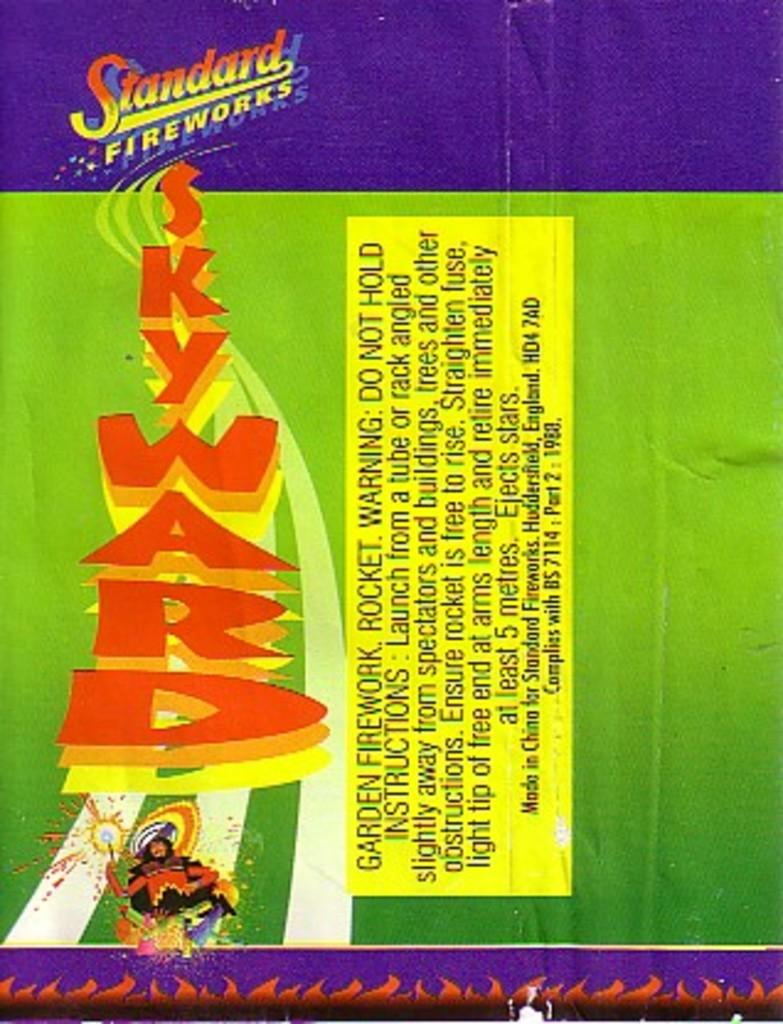<image>
Render a clear and concise summary of the photo. Standared fireworks from skyward that is on a fireworks box 